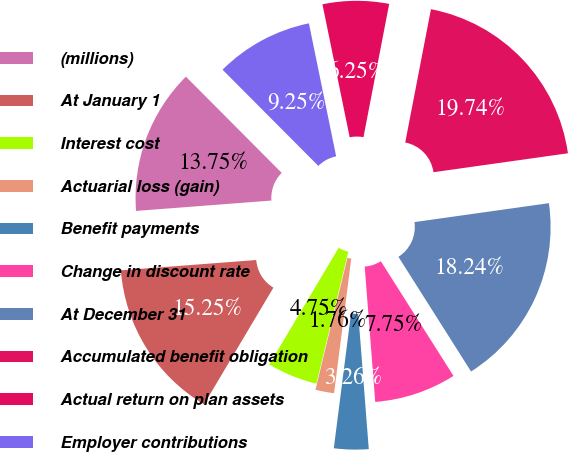Convert chart to OTSL. <chart><loc_0><loc_0><loc_500><loc_500><pie_chart><fcel>(millions)<fcel>At January 1<fcel>Interest cost<fcel>Actuarial loss (gain)<fcel>Benefit payments<fcel>Change in discount rate<fcel>At December 31<fcel>Accumulated benefit obligation<fcel>Actual return on plan assets<fcel>Employer contributions<nl><fcel>13.75%<fcel>15.25%<fcel>4.75%<fcel>1.76%<fcel>3.26%<fcel>7.75%<fcel>18.24%<fcel>19.74%<fcel>6.25%<fcel>9.25%<nl></chart> 